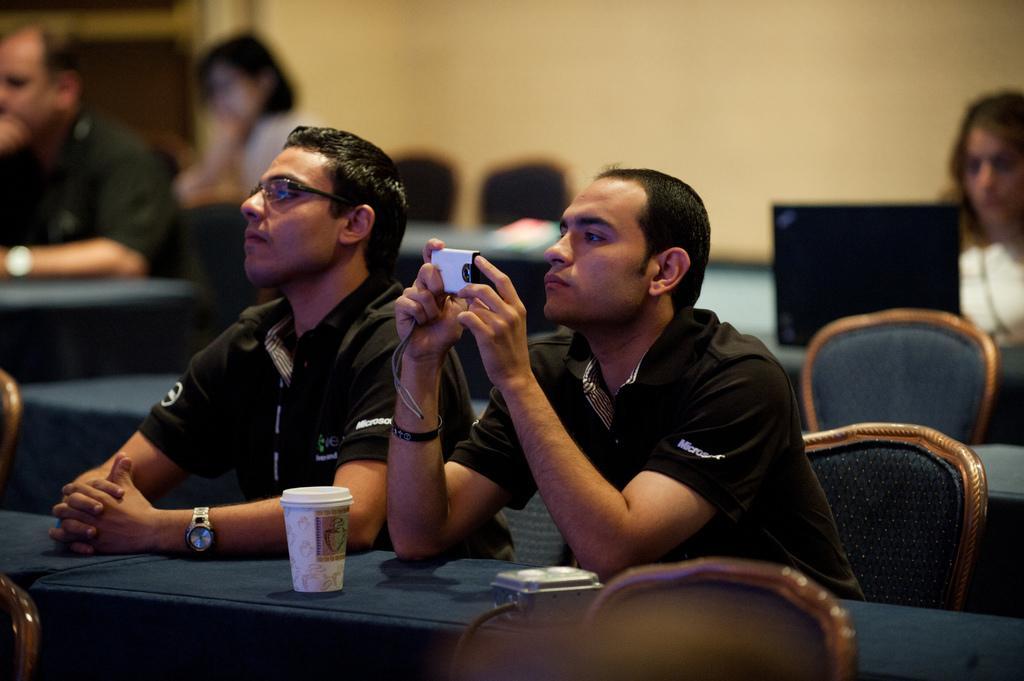How would you summarize this image in a sentence or two? In this image i can see 2 persons wearing black t shirts are sitting on the chairs in front of the desk, the person on the right side is holding a camera and a person on the left side is wearing a watch and glasses. On the desk I can see a cup and a box. In the background I can see few people sitting on chairs,a laptop and the wall. 